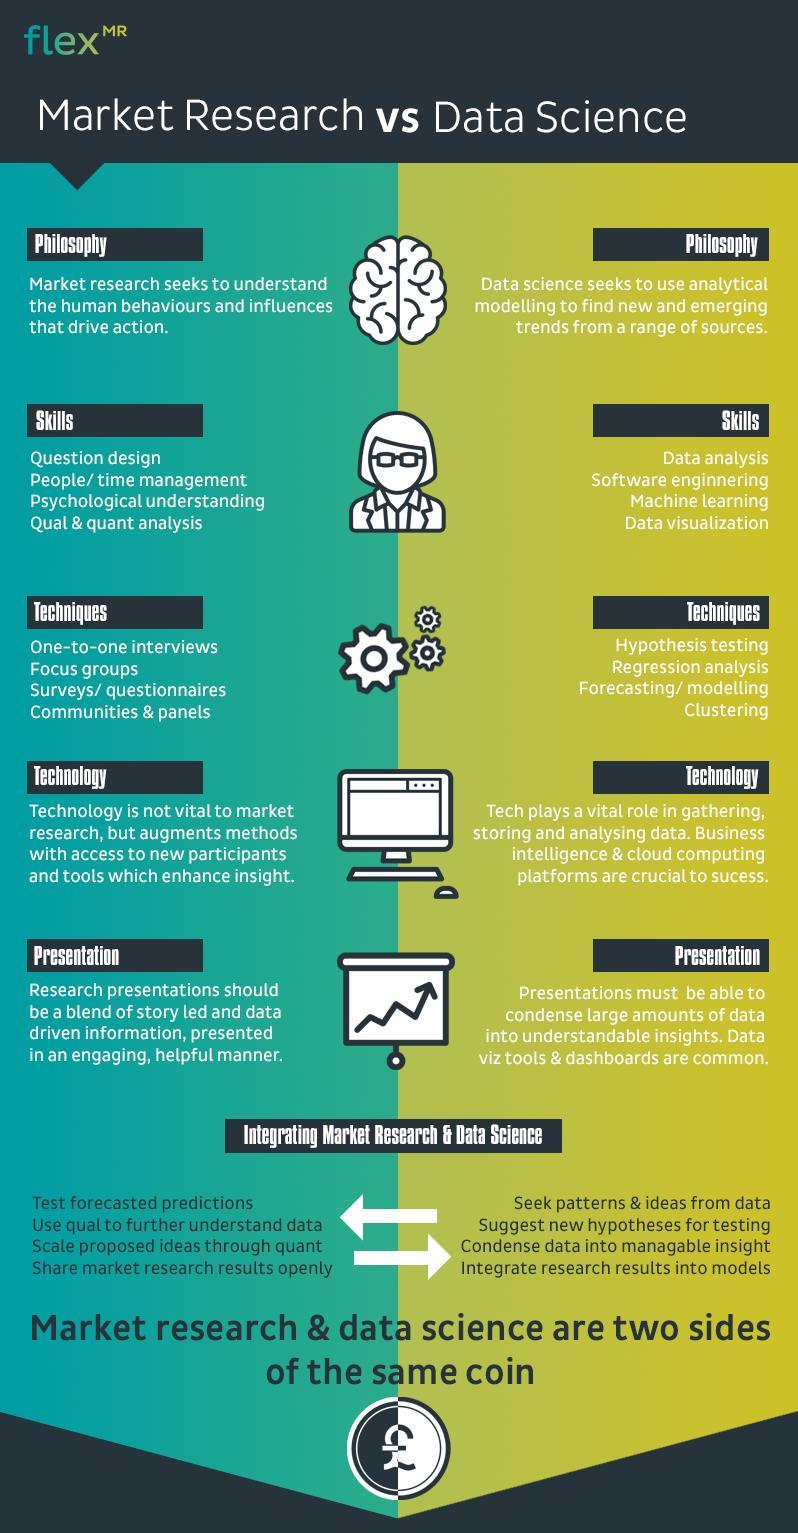How many points are under the heading "Skills" in Market Research?
Answer the question with a short phrase. 4 Which is the second technique used in the Market Research field? Focus groups Which is the fourth technique used in the Data Science field? Clustering Which is the third skill needed in the Data Science field? Machine Learning Which is the second skill needed in the Market Research field? People/time management Which is the second technique used in the Data Science field? Regression analysis 